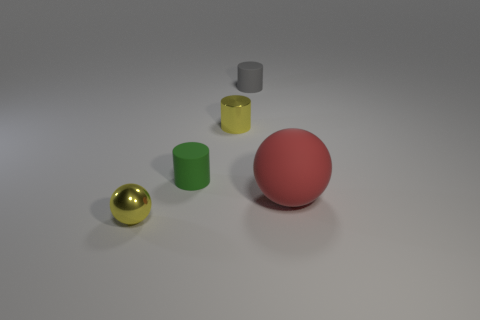There is another cylinder that is the same material as the gray cylinder; what is its color?
Your response must be concise. Green. There is a small shiny thing in front of the tiny matte cylinder that is in front of the small yellow metallic object behind the metal ball; what is its color?
Make the answer very short. Yellow. There is a metal sphere; is its size the same as the metal object that is behind the metal ball?
Provide a short and direct response. Yes. How many objects are either matte objects in front of the small gray rubber thing or small yellow metallic objects that are in front of the big matte object?
Keep it short and to the point. 3. The green object that is the same size as the metal sphere is what shape?
Keep it short and to the point. Cylinder. What shape is the small shiny object that is in front of the metallic object behind the ball right of the tiny gray cylinder?
Keep it short and to the point. Sphere. Is the number of yellow objects that are right of the tiny yellow sphere the same as the number of large spheres?
Your response must be concise. Yes. Is the yellow metallic ball the same size as the red rubber ball?
Keep it short and to the point. No. How many metallic objects are yellow cylinders or big cubes?
Give a very brief answer. 1. What is the material of the gray object that is the same size as the metallic cylinder?
Keep it short and to the point. Rubber. 